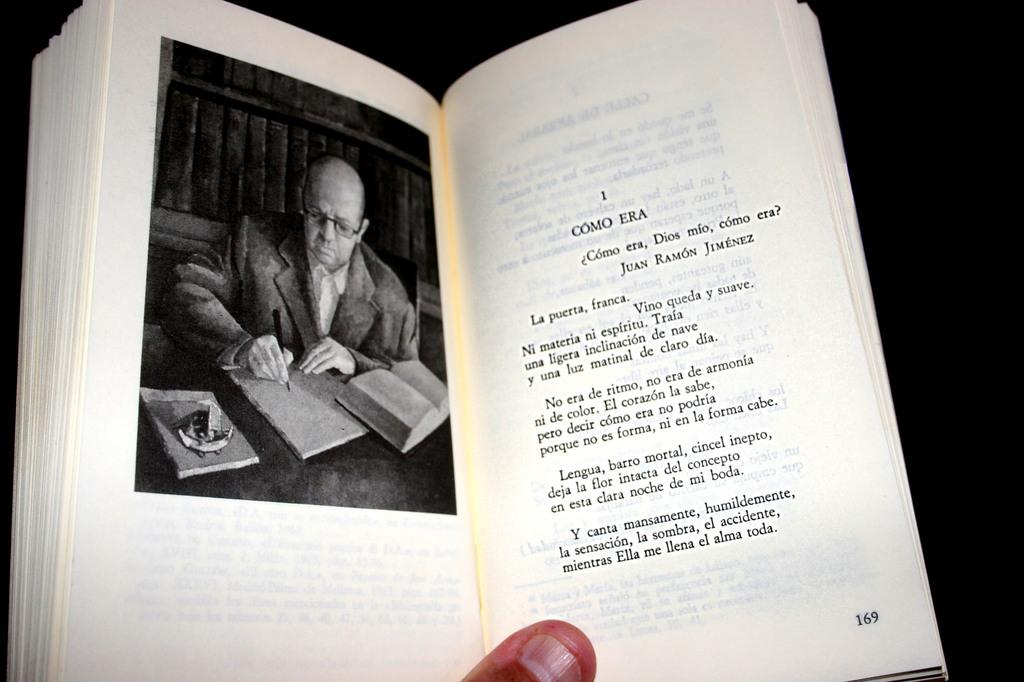Provide a one-sentence caption for the provided image. A book that is opened to page 169. 